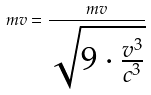Convert formula to latex. <formula><loc_0><loc_0><loc_500><loc_500>m v = \frac { m v } { \sqrt { 9 \cdot \frac { v ^ { 3 } } { c ^ { 3 } } } }</formula> 